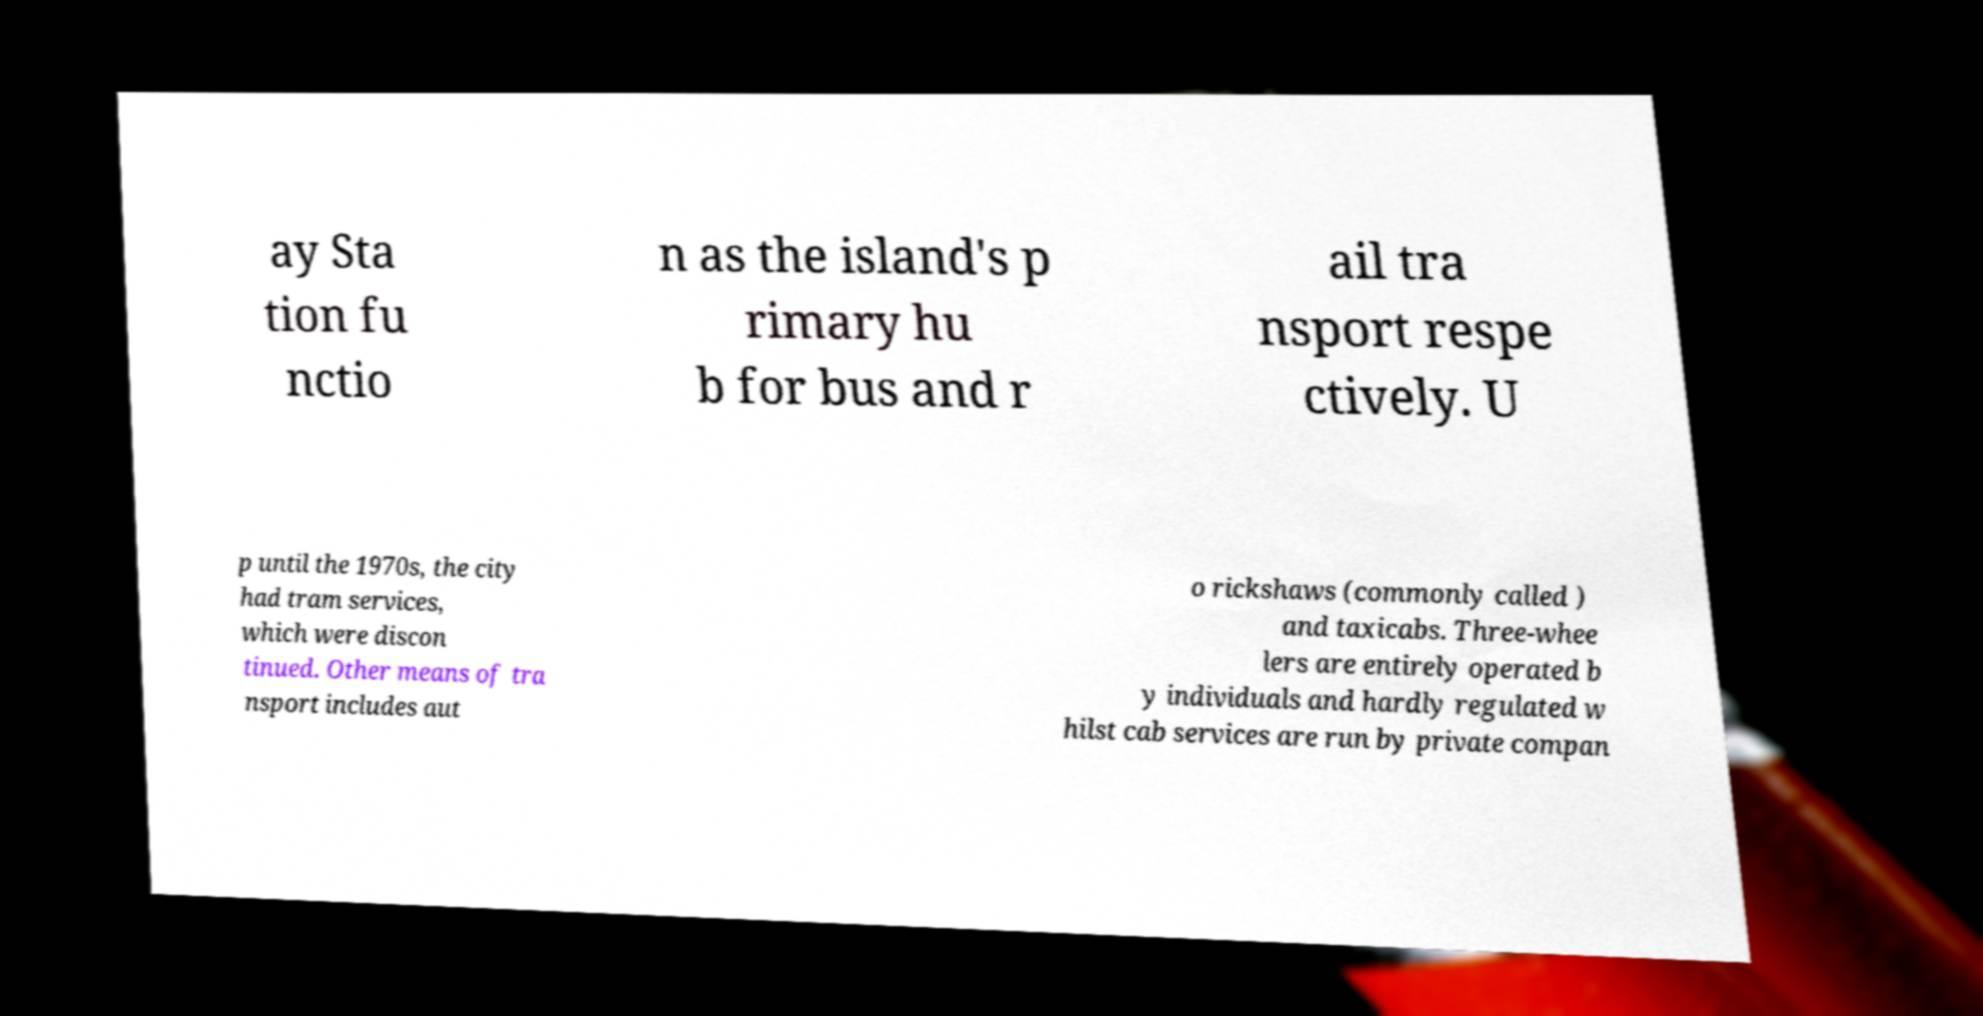There's text embedded in this image that I need extracted. Can you transcribe it verbatim? ay Sta tion fu nctio n as the island's p rimary hu b for bus and r ail tra nsport respe ctively. U p until the 1970s, the city had tram services, which were discon tinued. Other means of tra nsport includes aut o rickshaws (commonly called ) and taxicabs. Three-whee lers are entirely operated b y individuals and hardly regulated w hilst cab services are run by private compan 